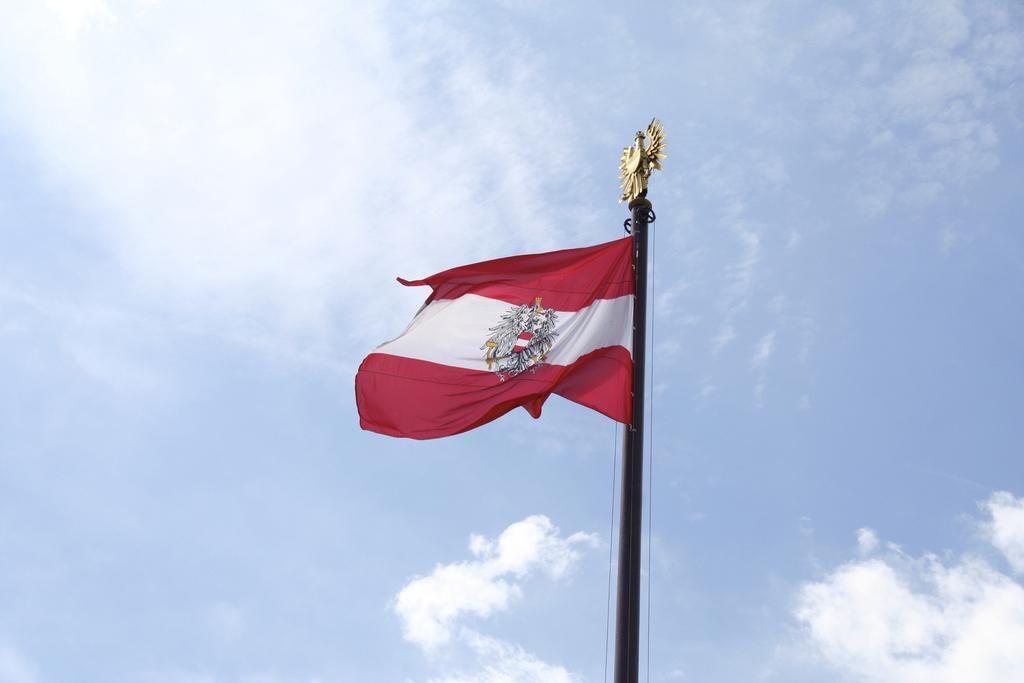In one or two sentences, can you explain what this image depicts? In the picture I can see a flag on the pole. In the background I can see the sky. 